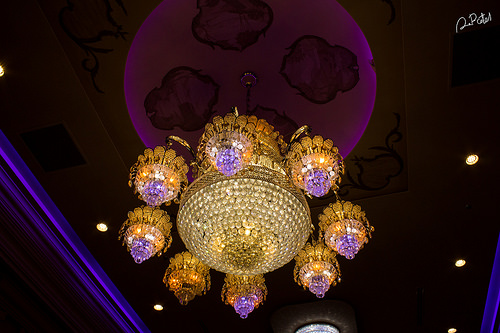<image>
Is there a chandelier on the ceiling? Yes. Looking at the image, I can see the chandelier is positioned on top of the ceiling, with the ceiling providing support. 